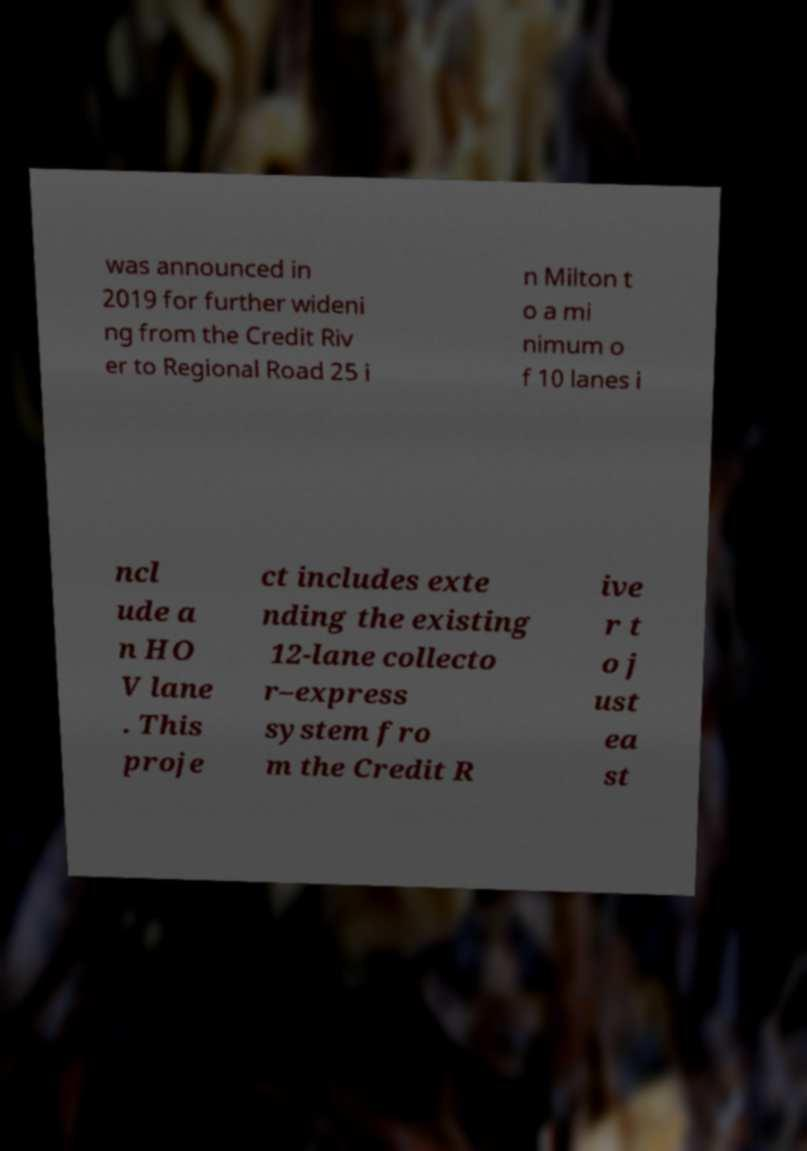What messages or text are displayed in this image? I need them in a readable, typed format. was announced in 2019 for further wideni ng from the Credit Riv er to Regional Road 25 i n Milton t o a mi nimum o f 10 lanes i ncl ude a n HO V lane . This proje ct includes exte nding the existing 12-lane collecto r–express system fro m the Credit R ive r t o j ust ea st 